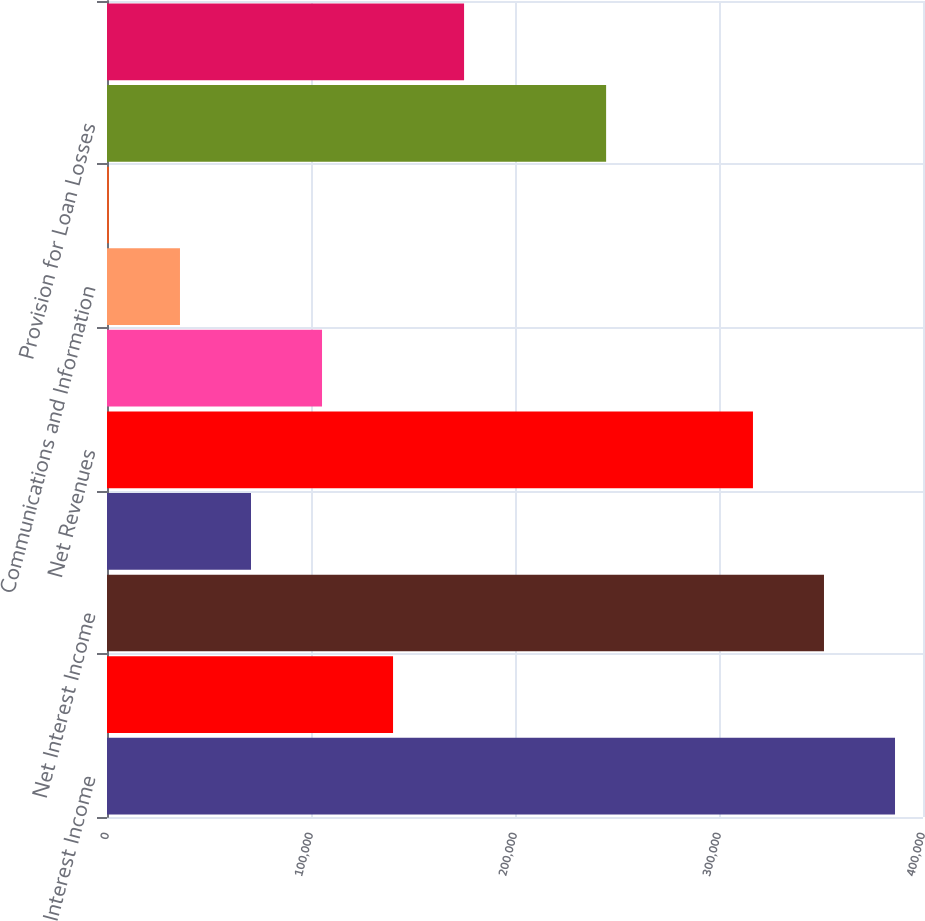<chart> <loc_0><loc_0><loc_500><loc_500><bar_chart><fcel>Interest Income<fcel>Interest Expense<fcel>Net Interest Income<fcel>Other Loss<fcel>Net Revenues<fcel>Employee Compensation and<fcel>Communications and Information<fcel>Occupancy and Equipment<fcel>Provision for Loan Losses<fcel>Other<nl><fcel>386280<fcel>140218<fcel>351464<fcel>70586.8<fcel>316649<fcel>105402<fcel>35771.4<fcel>956<fcel>244664<fcel>175033<nl></chart> 